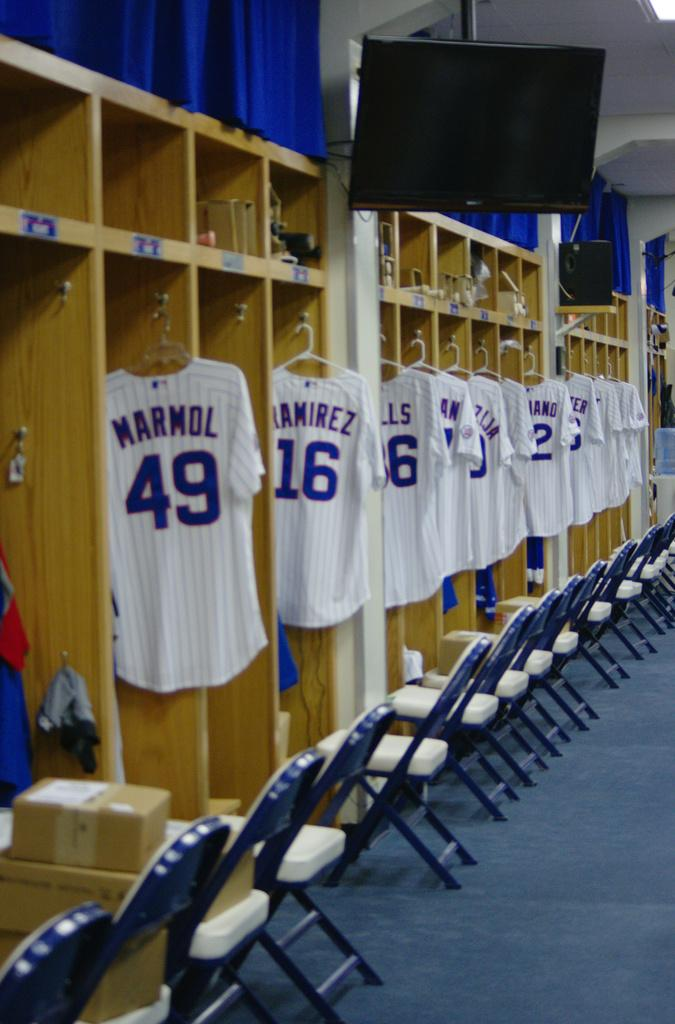Provide a one-sentence caption for the provided image. Out of the jerseys lined up in a locker room, Marmol's appears first. 